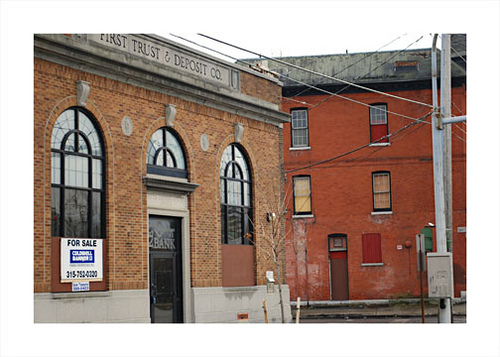<image>
Is there a sign in front of the street? No. The sign is not in front of the street. The spatial positioning shows a different relationship between these objects. 